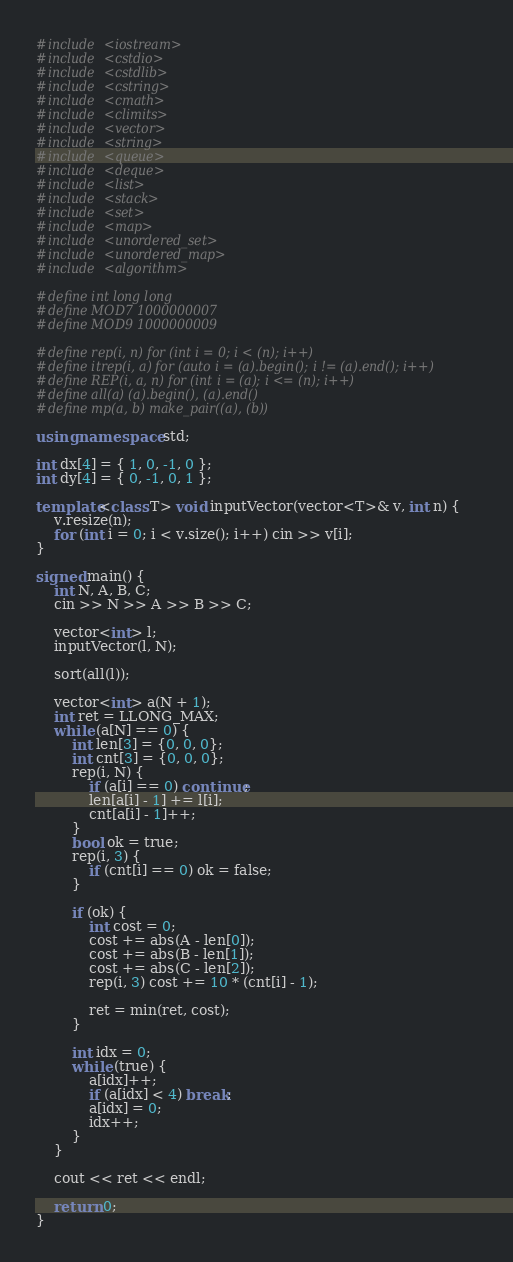Convert code to text. <code><loc_0><loc_0><loc_500><loc_500><_C++_>#include <iostream>
#include <cstdio>
#include <cstdlib>
#include <cstring>
#include <cmath>
#include <climits>
#include <vector>
#include <string>
#include <queue>
#include <deque>
#include <list>
#include <stack>
#include <set>
#include <map>
#include <unordered_set>
#include <unordered_map>
#include <algorithm>

#define int long long
#define MOD7 1000000007
#define MOD9 1000000009

#define rep(i, n) for (int i = 0; i < (n); i++)
#define itrep(i, a) for (auto i = (a).begin(); i != (a).end(); i++)
#define REP(i, a, n) for (int i = (a); i <= (n); i++)
#define all(a) (a).begin(), (a).end()
#define mp(a, b) make_pair((a), (b))

using namespace std;

int dx[4] = { 1, 0, -1, 0 };
int dy[4] = { 0, -1, 0, 1 };

template<class T> void inputVector(vector<T>& v, int n) {
    v.resize(n);
    for (int i = 0; i < v.size(); i++) cin >> v[i];
}

signed main() {
    int N, A, B, C;
    cin >> N >> A >> B >> C;

    vector<int> l;
    inputVector(l, N);

    sort(all(l));

    vector<int> a(N + 1);
    int ret = LLONG_MAX;
    while (a[N] == 0) {
        int len[3] = {0, 0, 0};
        int cnt[3] = {0, 0, 0};
        rep(i, N) {
            if (a[i] == 0) continue;
            len[a[i] - 1] += l[i];
            cnt[a[i] - 1]++;
        }
        bool ok = true;
        rep(i, 3) {
            if (cnt[i] == 0) ok = false;
        }

        if (ok) {
            int cost = 0;
            cost += abs(A - len[0]);
            cost += abs(B - len[1]);
            cost += abs(C - len[2]);
            rep(i, 3) cost += 10 * (cnt[i] - 1);

            ret = min(ret, cost);
        }

        int idx = 0;
        while (true) {
            a[idx]++;
            if (a[idx] < 4) break;
            a[idx] = 0;
            idx++;
        }
    }

    cout << ret << endl;

    return 0;
}
</code> 